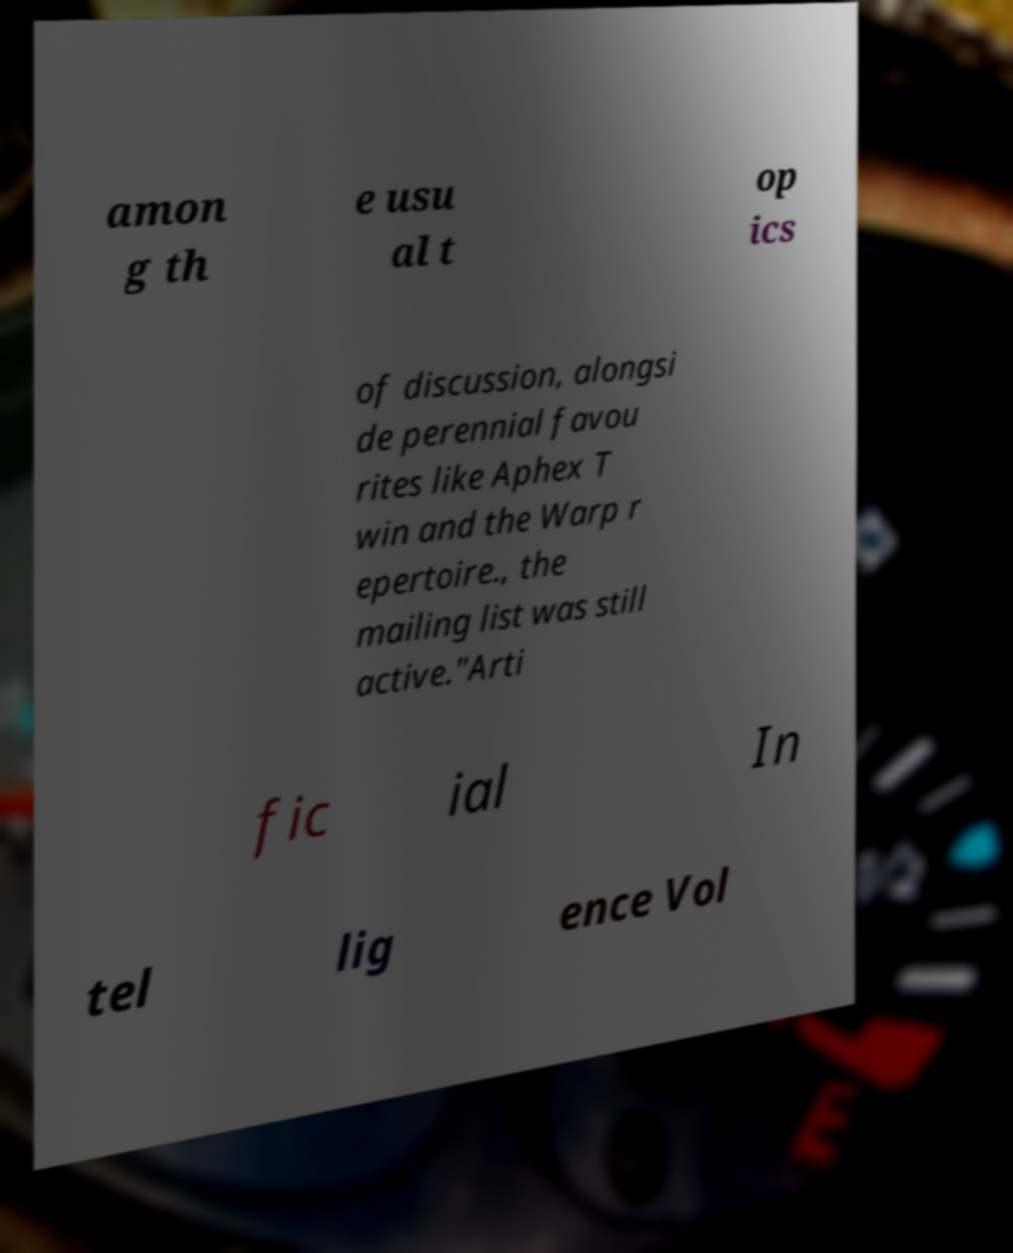Could you extract and type out the text from this image? amon g th e usu al t op ics of discussion, alongsi de perennial favou rites like Aphex T win and the Warp r epertoire., the mailing list was still active."Arti fic ial In tel lig ence Vol 